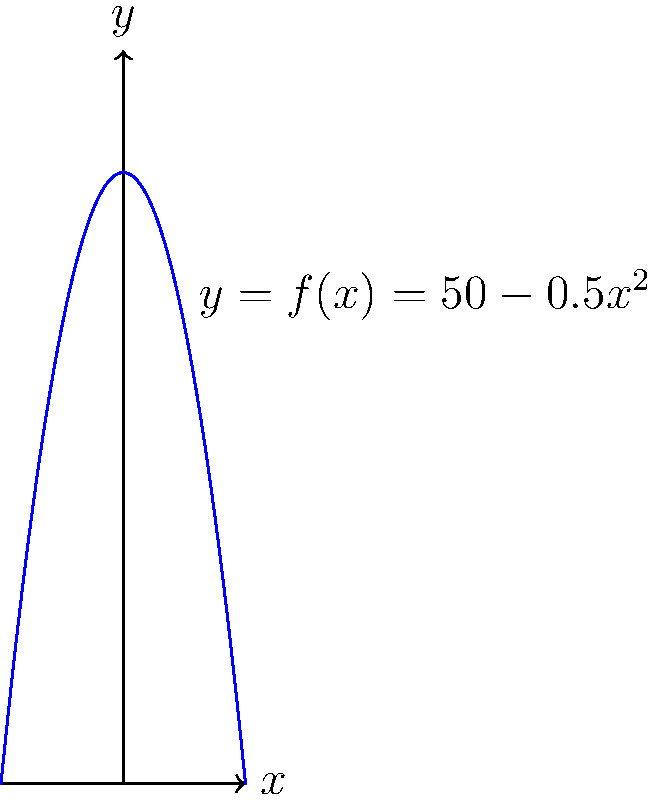An Aztec pyramid has a profile described by the function $f(x)=50-0.5x^2$, where $x$ is measured in meters from the center of the base and $f(x)$ gives the height in meters. Calculate the surface area of one side of the pyramid, assuming it extends from $x=-10$ to $x=10$. To find the surface area of one side of the pyramid, we need to use the arc length formula and integrate it over the given interval. Here's how we proceed:

1) The arc length formula for a function $y=f(x)$ is:

   $$L = \int_{a}^{b} \sqrt{1 + \left(\frac{dy}{dx}\right)^2} dx$$

2) We need to find $\frac{dy}{dx}$:
   
   $$f(x) = 50 - 0.5x^2$$
   $$\frac{df}{dx} = -x$$

3) Substituting into the arc length formula:

   $$L = \int_{-10}^{10} \sqrt{1 + (-x)^2} dx = \int_{-10}^{10} \sqrt{1 + x^2} dx$$

4) This integral doesn't have an elementary antiderivative. We can solve it using the hyperbolic substitution:

   Let $x = \sinh(u)$, then $dx = \cosh(u) du$
   
   When $x = -10$, $u = \sinh^{-1}(-10)$
   When $x = 10$, $u = \sinh^{-1}(10)$

5) Substituting:

   $$L = \int_{\sinh^{-1}(-10)}^{\sinh^{-1}(10)} \sqrt{1 + \sinh^2(u)} \cosh(u) du$$

6) Simplify using the identity $1 + \sinh^2(u) = \cosh^2(u)$:

   $$L = \int_{\sinh^{-1}(-10)}^{\sinh^{-1}(10)} \cosh^2(u) du$$

7) Use the identity $\cosh^2(u) = \frac{1}{2}(\cosh(2u) + 1)$:

   $$L = \int_{\sinh^{-1}(-10)}^{\sinh^{-1}(10)} \frac{1}{2}(\cosh(2u) + 1) du$$

8) Integrate:

   $$L = \left[\frac{1}{4}\sinh(2u) + \frac{1}{2}u\right]_{\sinh^{-1}(-10)}^{\sinh^{-1}(10)}$$

9) Evaluate the limits:

   $$L = \left[\frac{1}{4}\sinh(2\sinh^{-1}(10)) + \frac{1}{2}\sinh^{-1}(10)\right] - \left[\frac{1}{4}\sinh(2\sinh^{-1}(-10)) + \frac{1}{2}\sinh^{-1}(-10)\right]$$

10) Simplify:

    $$L = \frac{1}{2}\sinh(2\sinh^{-1}(10)) + \sinh^{-1}(10) \approx 101.99$$

Therefore, the surface area of one side of the pyramid is approximately 101.99 square meters.
Answer: 101.99 m² 